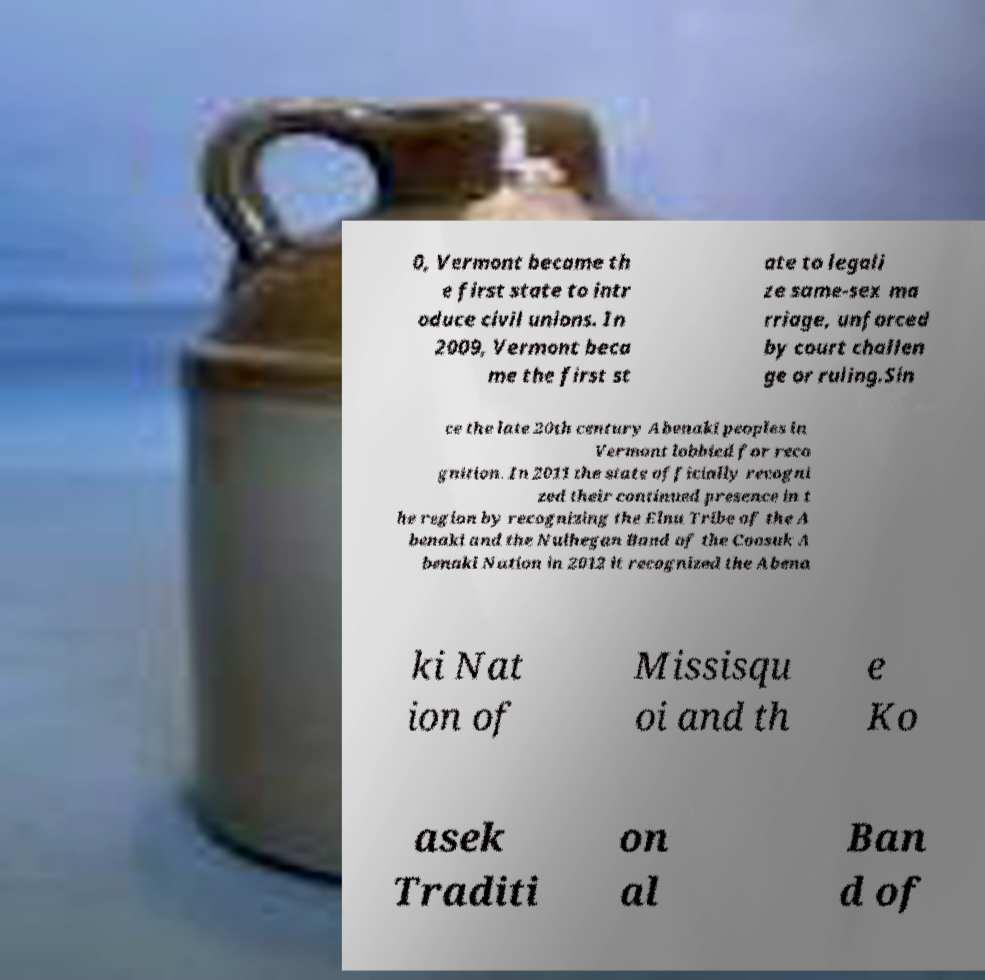Please read and relay the text visible in this image. What does it say? 0, Vermont became th e first state to intr oduce civil unions. In 2009, Vermont beca me the first st ate to legali ze same-sex ma rriage, unforced by court challen ge or ruling.Sin ce the late 20th century Abenaki peoples in Vermont lobbied for reco gnition. In 2011 the state officially recogni zed their continued presence in t he region by recognizing the Elnu Tribe of the A benaki and the Nulhegan Band of the Coosuk A benaki Nation in 2012 it recognized the Abena ki Nat ion of Missisqu oi and th e Ko asek Traditi on al Ban d of 